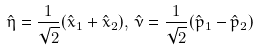Convert formula to latex. <formula><loc_0><loc_0><loc_500><loc_500>\hat { \eta } = \frac { 1 } { \sqrt { 2 } } ( \hat { x } _ { 1 } + \hat { x } _ { 2 } ) , \, \hat { \nu } = \frac { 1 } { \sqrt { 2 } } ( \hat { p } _ { 1 } - \hat { p } _ { 2 } )</formula> 